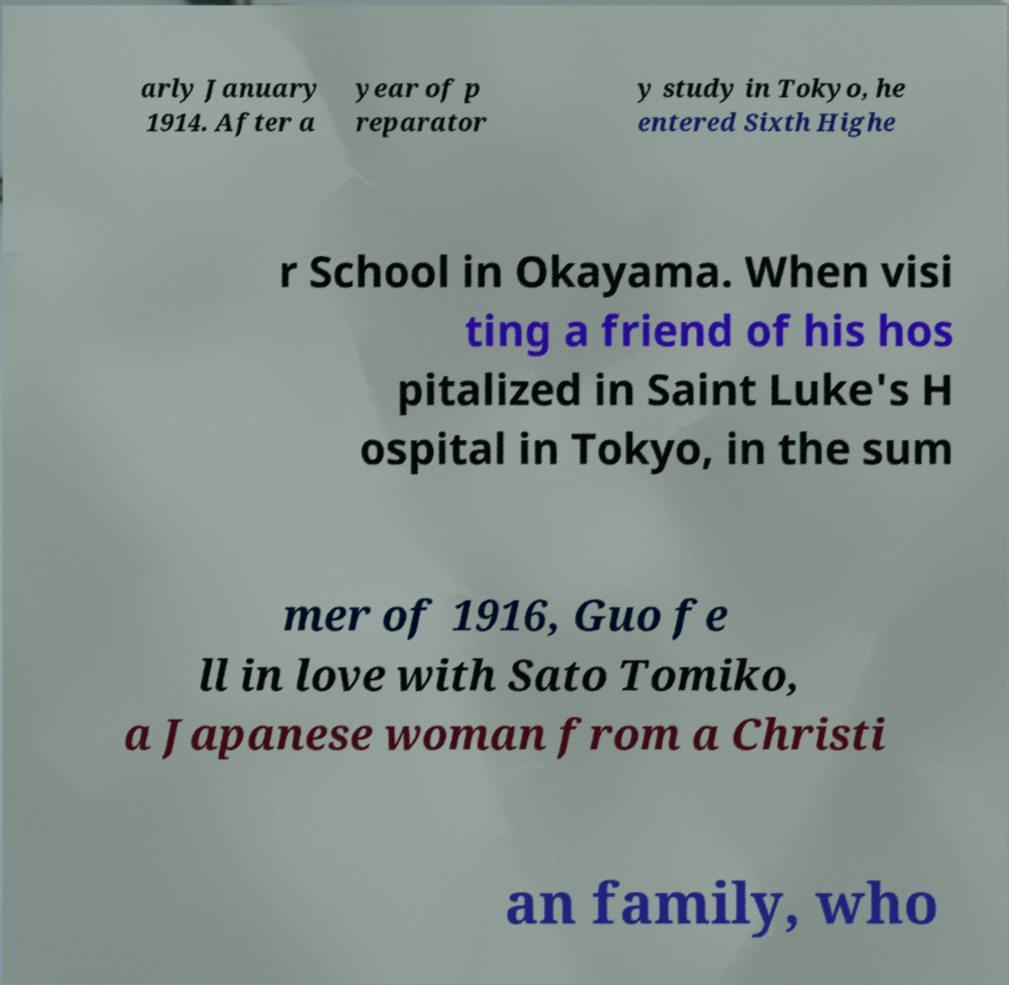For documentation purposes, I need the text within this image transcribed. Could you provide that? arly January 1914. After a year of p reparator y study in Tokyo, he entered Sixth Highe r School in Okayama. When visi ting a friend of his hos pitalized in Saint Luke's H ospital in Tokyo, in the sum mer of 1916, Guo fe ll in love with Sato Tomiko, a Japanese woman from a Christi an family, who 